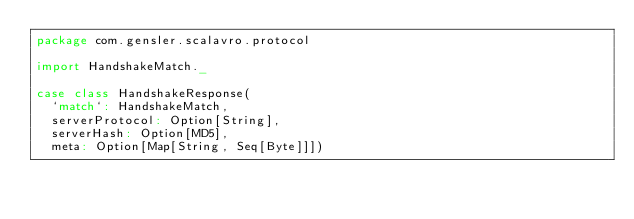<code> <loc_0><loc_0><loc_500><loc_500><_Scala_>package com.gensler.scalavro.protocol

import HandshakeMatch._

case class HandshakeResponse(
  `match`: HandshakeMatch,
  serverProtocol: Option[String],
  serverHash: Option[MD5],
  meta: Option[Map[String, Seq[Byte]]])
</code> 